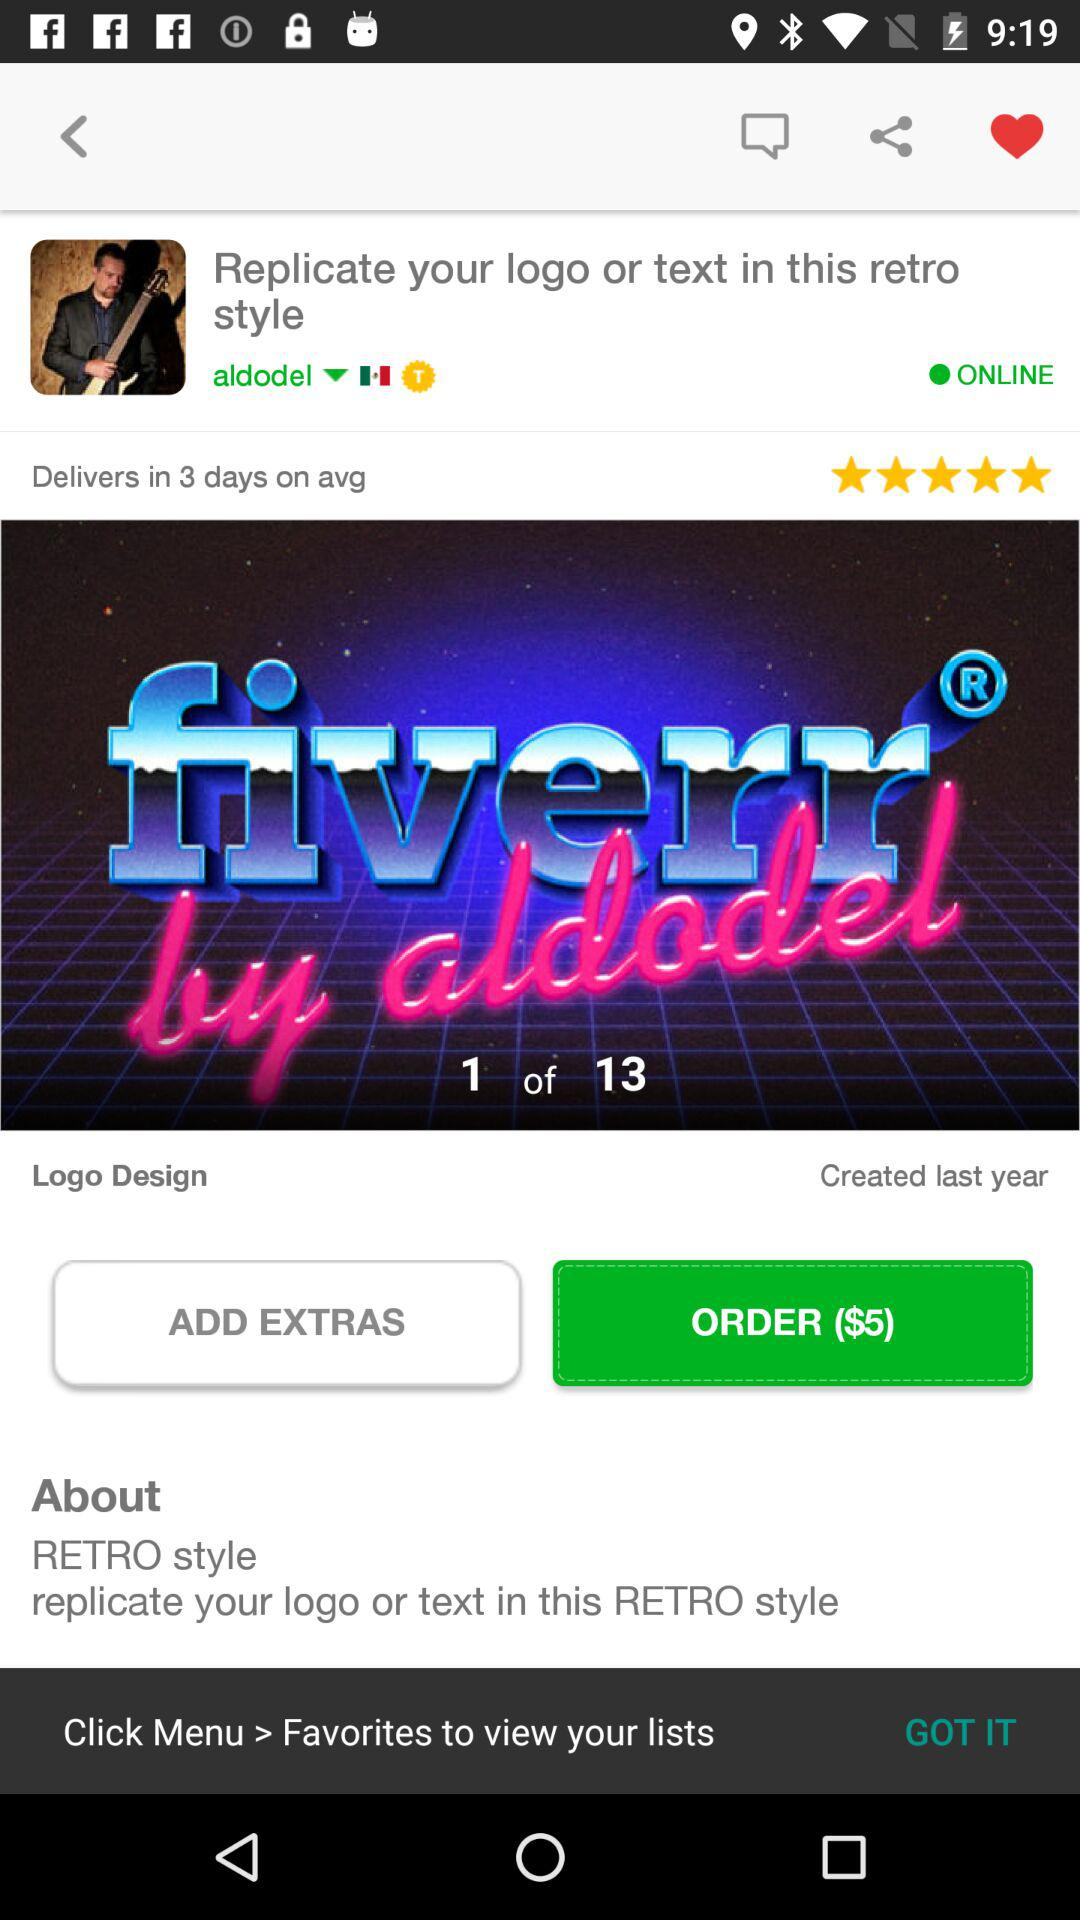What is the price of the order? The price of the order is $5. 